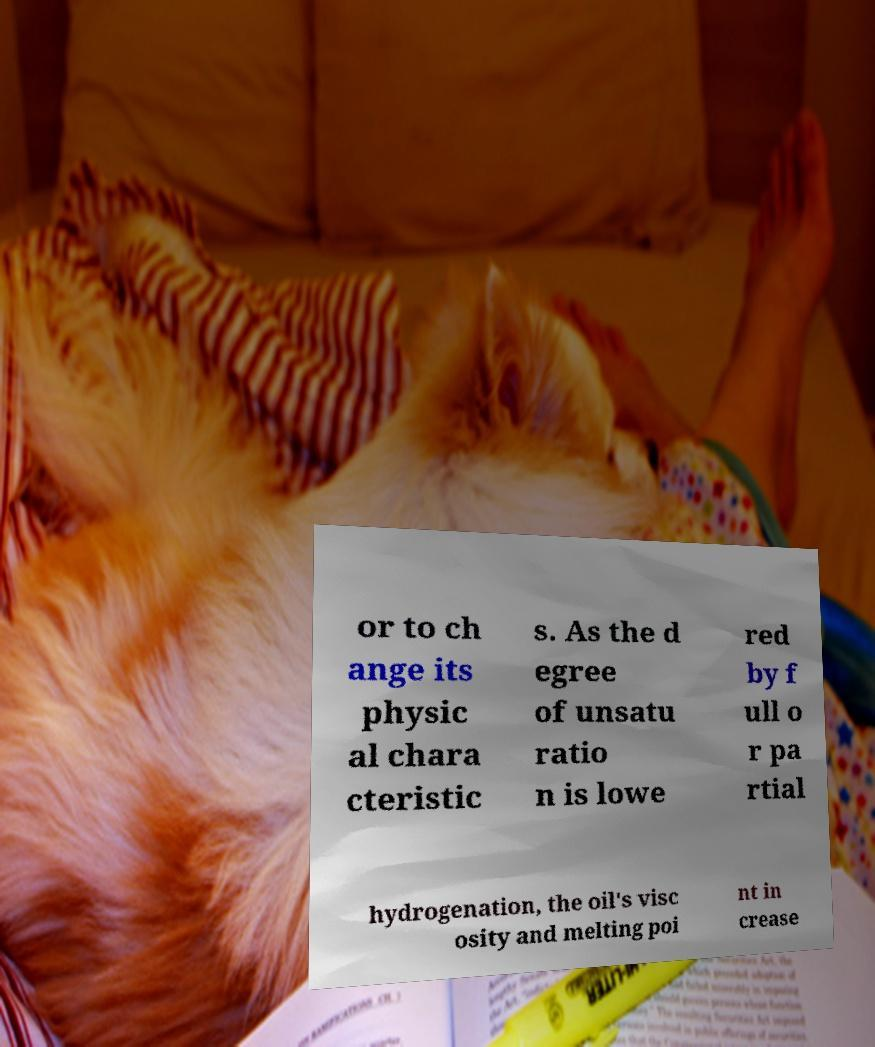Could you assist in decoding the text presented in this image and type it out clearly? or to ch ange its physic al chara cteristic s. As the d egree of unsatu ratio n is lowe red by f ull o r pa rtial hydrogenation, the oil's visc osity and melting poi nt in crease 